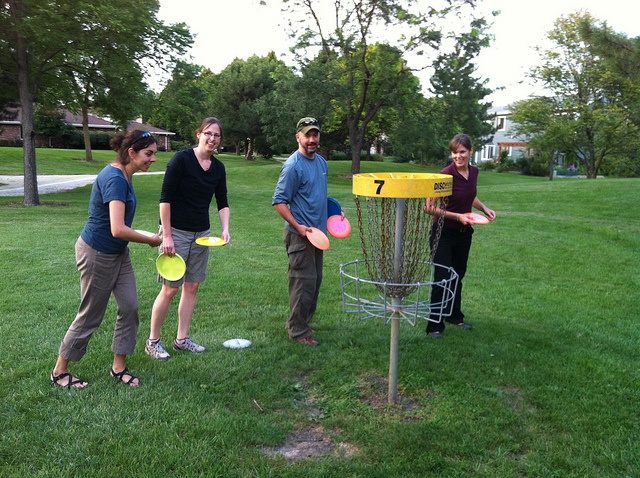Describe the objects in this image and their specific colors. I can see people in black, gray, and navy tones, people in black, gray, brown, and lightpink tones, people in black, blue, and gray tones, people in black, gray, brown, and maroon tones, and frisbee in black, khaki, and olive tones in this image. 